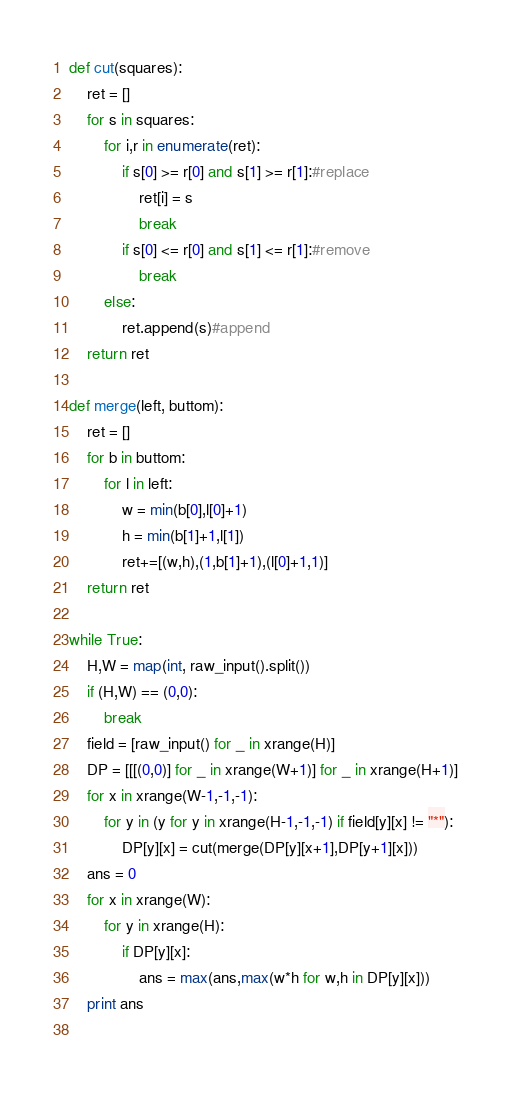<code> <loc_0><loc_0><loc_500><loc_500><_Python_>def cut(squares):
    ret = []
    for s in squares:
        for i,r in enumerate(ret):
            if s[0] >= r[0] and s[1] >= r[1]:#replace
                ret[i] = s
                break
            if s[0] <= r[0] and s[1] <= r[1]:#remove
                break
        else:
            ret.append(s)#append
    return ret

def merge(left, buttom):
    ret = []
    for b in buttom:
        for l in left:
            w = min(b[0],l[0]+1)
            h = min(b[1]+1,l[1])
            ret+=[(w,h),(1,b[1]+1),(l[0]+1,1)]
    return ret

while True:
    H,W = map(int, raw_input().split())
    if (H,W) == (0,0):
        break
    field = [raw_input() for _ in xrange(H)]
    DP = [[[(0,0)] for _ in xrange(W+1)] for _ in xrange(H+1)]    
    for x in xrange(W-1,-1,-1):
        for y in (y for y in xrange(H-1,-1,-1) if field[y][x] != "*"):
            DP[y][x] = cut(merge(DP[y][x+1],DP[y+1][x]))
    ans = 0
    for x in xrange(W):
        for y in xrange(H):
            if DP[y][x]:
                ans = max(ans,max(w*h for w,h in DP[y][x]))
    print ans
            </code> 